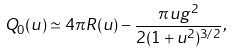<formula> <loc_0><loc_0><loc_500><loc_500>Q _ { 0 } ( u ) \simeq 4 \pi R ( u ) - \frac { \pi u g ^ { 2 } } { 2 ( 1 + u ^ { 2 } ) ^ { 3 / 2 } } ,</formula> 